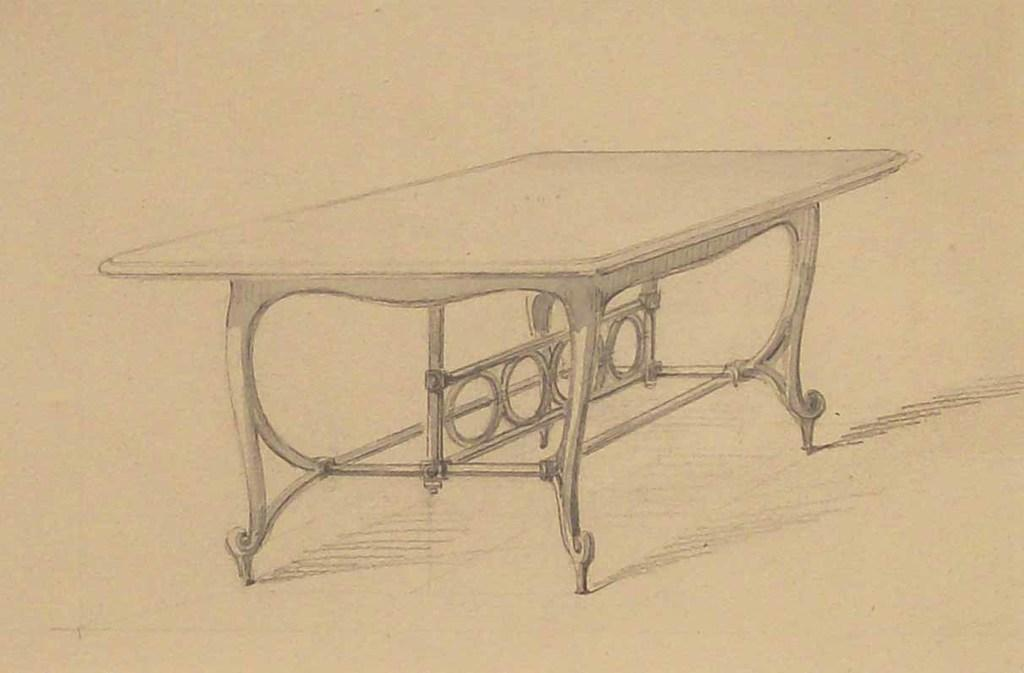What is the main subject of the image? There is an art piece in the image. What is included in the art piece? The art piece contains a table. Where is the table located within the art piece? The table is in the middle of the image. How does the art piece say good-bye to the viewer? The art piece does not have the ability to say good-bye, as it is an inanimate object. Is there a throne present in the art piece? There is no mention of a throne in the provided facts, so we cannot confirm its presence in the image. 